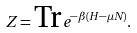Convert formula to latex. <formula><loc_0><loc_0><loc_500><loc_500>Z = \text {Tr} \, e ^ { - \beta ( H - \mu N ) } .</formula> 